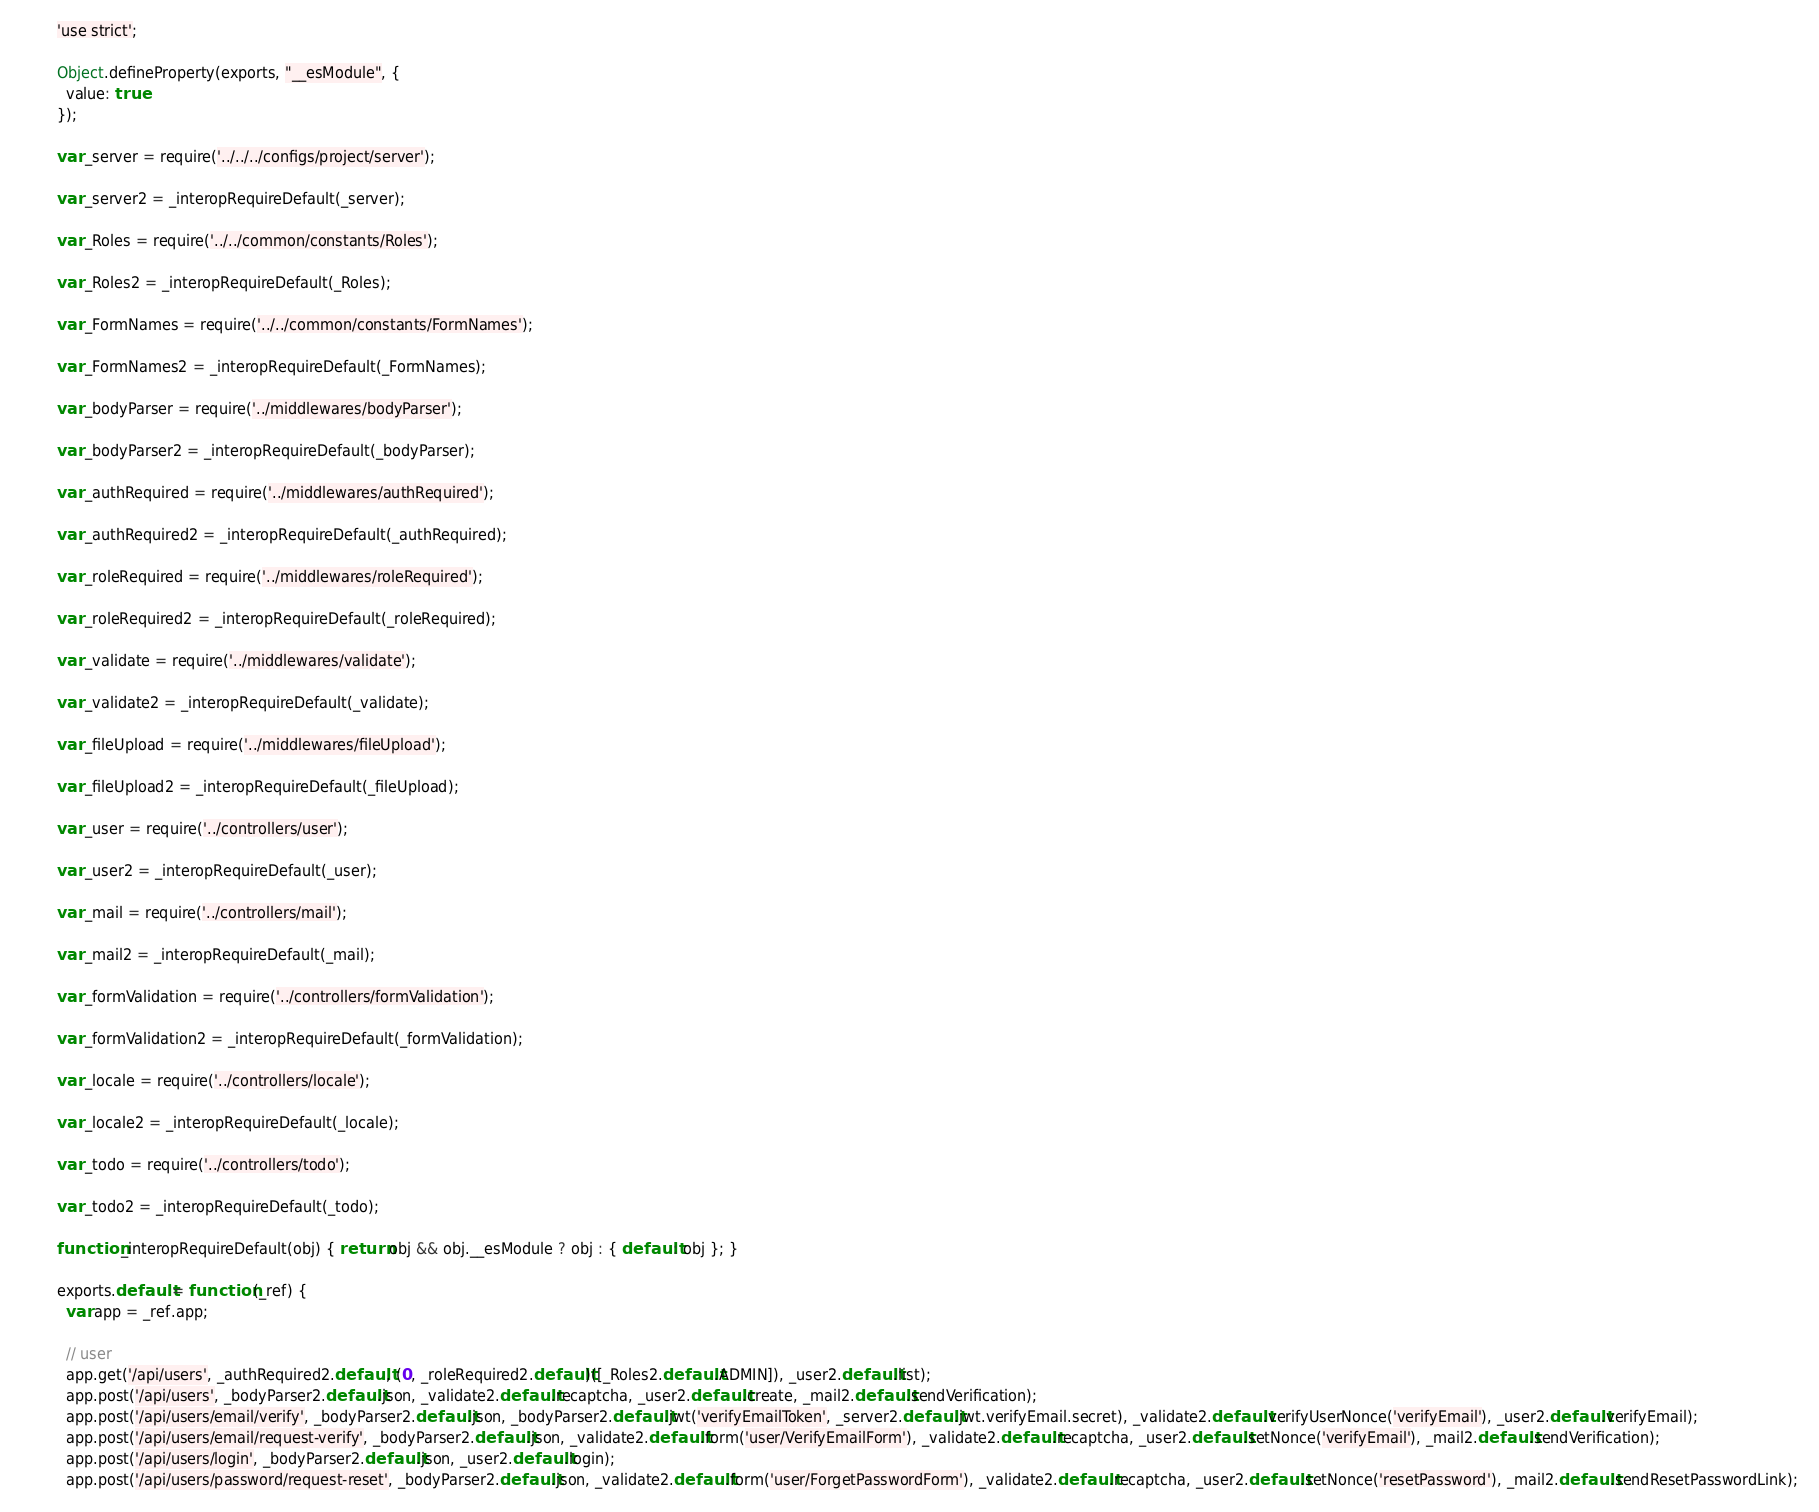Convert code to text. <code><loc_0><loc_0><loc_500><loc_500><_JavaScript_>'use strict';

Object.defineProperty(exports, "__esModule", {
  value: true
});

var _server = require('../../../configs/project/server');

var _server2 = _interopRequireDefault(_server);

var _Roles = require('../../common/constants/Roles');

var _Roles2 = _interopRequireDefault(_Roles);

var _FormNames = require('../../common/constants/FormNames');

var _FormNames2 = _interopRequireDefault(_FormNames);

var _bodyParser = require('../middlewares/bodyParser');

var _bodyParser2 = _interopRequireDefault(_bodyParser);

var _authRequired = require('../middlewares/authRequired');

var _authRequired2 = _interopRequireDefault(_authRequired);

var _roleRequired = require('../middlewares/roleRequired');

var _roleRequired2 = _interopRequireDefault(_roleRequired);

var _validate = require('../middlewares/validate');

var _validate2 = _interopRequireDefault(_validate);

var _fileUpload = require('../middlewares/fileUpload');

var _fileUpload2 = _interopRequireDefault(_fileUpload);

var _user = require('../controllers/user');

var _user2 = _interopRequireDefault(_user);

var _mail = require('../controllers/mail');

var _mail2 = _interopRequireDefault(_mail);

var _formValidation = require('../controllers/formValidation');

var _formValidation2 = _interopRequireDefault(_formValidation);

var _locale = require('../controllers/locale');

var _locale2 = _interopRequireDefault(_locale);

var _todo = require('../controllers/todo');

var _todo2 = _interopRequireDefault(_todo);

function _interopRequireDefault(obj) { return obj && obj.__esModule ? obj : { default: obj }; }

exports.default = function (_ref) {
  var app = _ref.app;

  // user
  app.get('/api/users', _authRequired2.default, (0, _roleRequired2.default)([_Roles2.default.ADMIN]), _user2.default.list);
  app.post('/api/users', _bodyParser2.default.json, _validate2.default.recaptcha, _user2.default.create, _mail2.default.sendVerification);
  app.post('/api/users/email/verify', _bodyParser2.default.json, _bodyParser2.default.jwt('verifyEmailToken', _server2.default.jwt.verifyEmail.secret), _validate2.default.verifyUserNonce('verifyEmail'), _user2.default.verifyEmail);
  app.post('/api/users/email/request-verify', _bodyParser2.default.json, _validate2.default.form('user/VerifyEmailForm'), _validate2.default.recaptcha, _user2.default.setNonce('verifyEmail'), _mail2.default.sendVerification);
  app.post('/api/users/login', _bodyParser2.default.json, _user2.default.login);
  app.post('/api/users/password/request-reset', _bodyParser2.default.json, _validate2.default.form('user/ForgetPasswordForm'), _validate2.default.recaptcha, _user2.default.setNonce('resetPassword'), _mail2.default.sendResetPasswordLink);</code> 